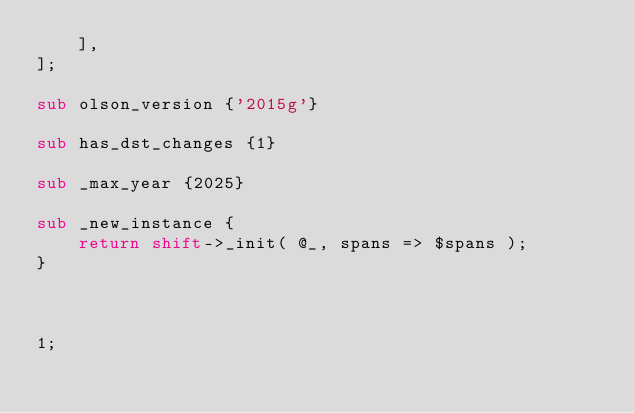Convert code to text. <code><loc_0><loc_0><loc_500><loc_500><_Perl_>    ],
];

sub olson_version {'2015g'}

sub has_dst_changes {1}

sub _max_year {2025}

sub _new_instance {
    return shift->_init( @_, spans => $spans );
}



1;

</code> 